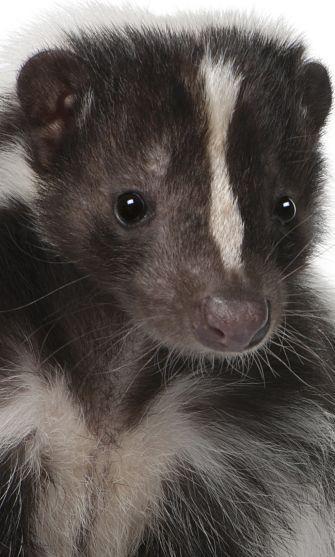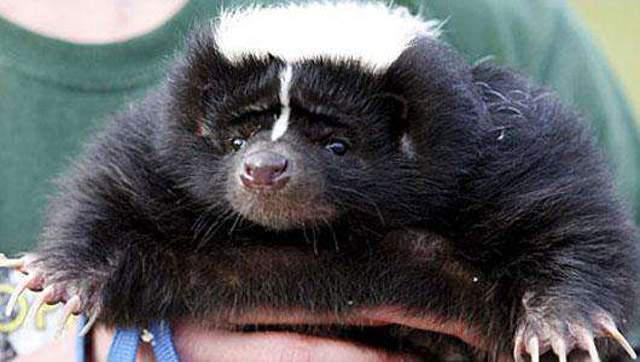The first image is the image on the left, the second image is the image on the right. Given the left and right images, does the statement "The left image features a skunk with a thin white stripe down its rightward-turned head, and the right image features a forward-facing skunk that does not have white fur covering the top of its head." hold true? Answer yes or no. No. The first image is the image on the left, the second image is the image on the right. For the images shown, is this caption "Four eyes are visible." true? Answer yes or no. Yes. 